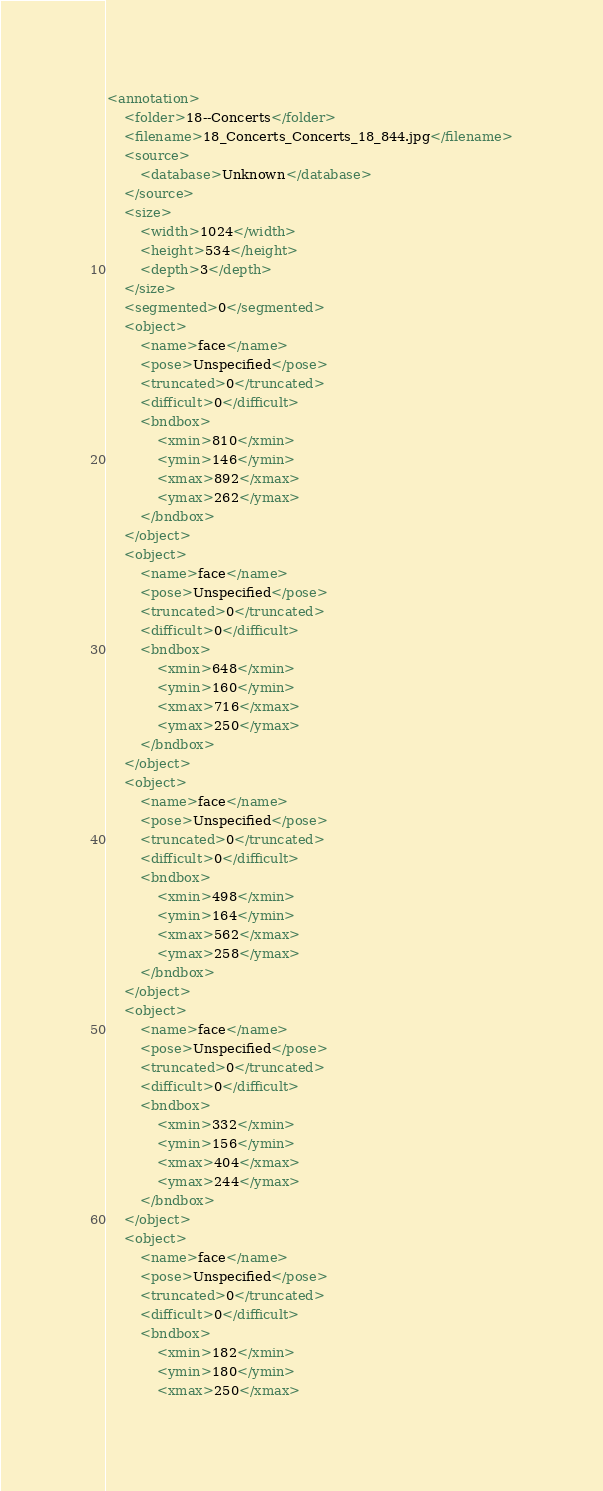<code> <loc_0><loc_0><loc_500><loc_500><_XML_><annotation>
    <folder>18--Concerts</folder>
    <filename>18_Concerts_Concerts_18_844.jpg</filename>
    <source>
        <database>Unknown</database>
    </source>
    <size>
        <width>1024</width>
        <height>534</height>
        <depth>3</depth>
    </size>
    <segmented>0</segmented>
    <object>
        <name>face</name>
        <pose>Unspecified</pose>
        <truncated>0</truncated>
        <difficult>0</difficult>
        <bndbox>
            <xmin>810</xmin>
            <ymin>146</ymin>
            <xmax>892</xmax>
            <ymax>262</ymax>
        </bndbox>
    </object>
    <object>
        <name>face</name>
        <pose>Unspecified</pose>
        <truncated>0</truncated>
        <difficult>0</difficult>
        <bndbox>
            <xmin>648</xmin>
            <ymin>160</ymin>
            <xmax>716</xmax>
            <ymax>250</ymax>
        </bndbox>
    </object>
    <object>
        <name>face</name>
        <pose>Unspecified</pose>
        <truncated>0</truncated>
        <difficult>0</difficult>
        <bndbox>
            <xmin>498</xmin>
            <ymin>164</ymin>
            <xmax>562</xmax>
            <ymax>258</ymax>
        </bndbox>
    </object>
    <object>
        <name>face</name>
        <pose>Unspecified</pose>
        <truncated>0</truncated>
        <difficult>0</difficult>
        <bndbox>
            <xmin>332</xmin>
            <ymin>156</ymin>
            <xmax>404</xmax>
            <ymax>244</ymax>
        </bndbox>
    </object>
    <object>
        <name>face</name>
        <pose>Unspecified</pose>
        <truncated>0</truncated>
        <difficult>0</difficult>
        <bndbox>
            <xmin>182</xmin>
            <ymin>180</ymin>
            <xmax>250</xmax></code> 